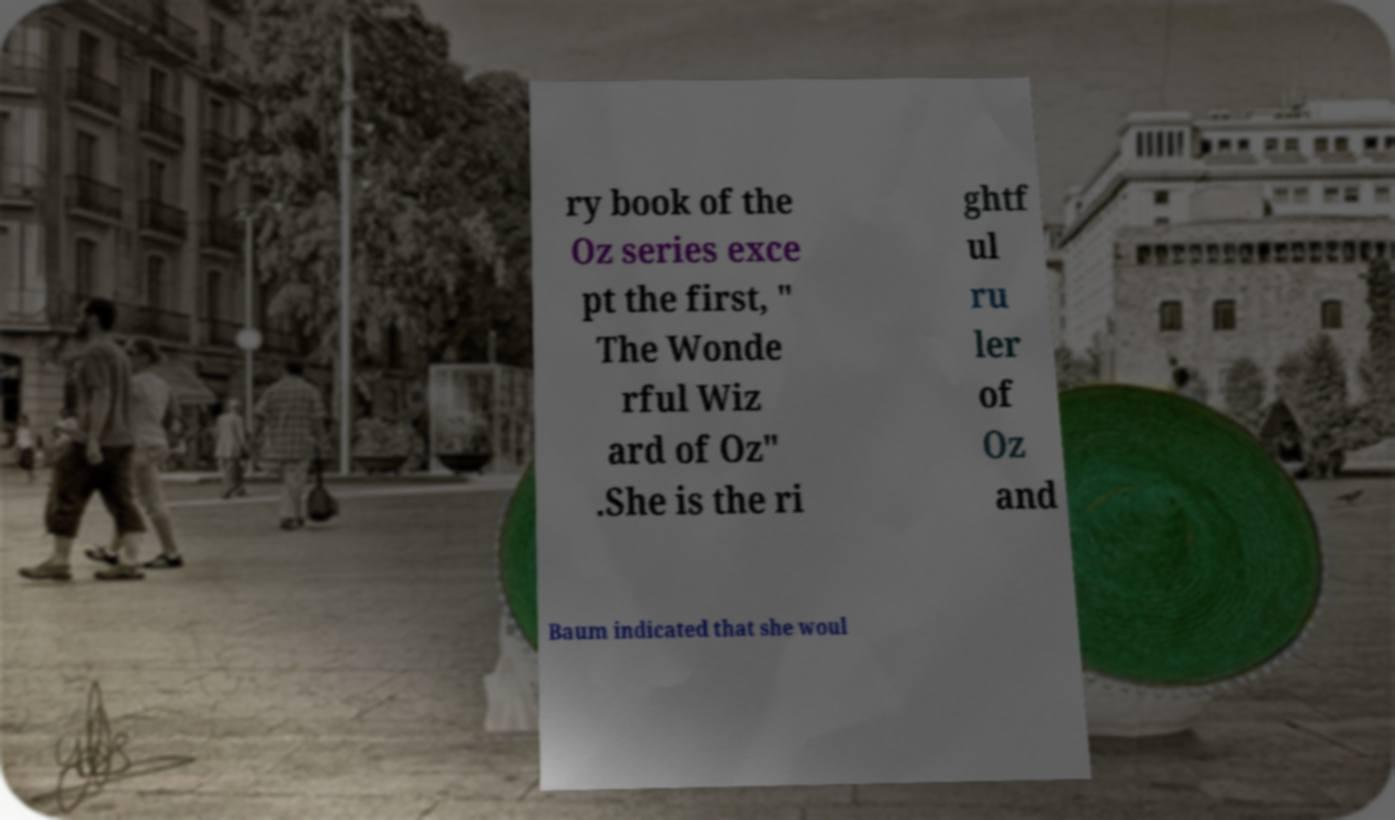What messages or text are displayed in this image? I need them in a readable, typed format. ry book of the Oz series exce pt the first, " The Wonde rful Wiz ard of Oz" .She is the ri ghtf ul ru ler of Oz and Baum indicated that she woul 